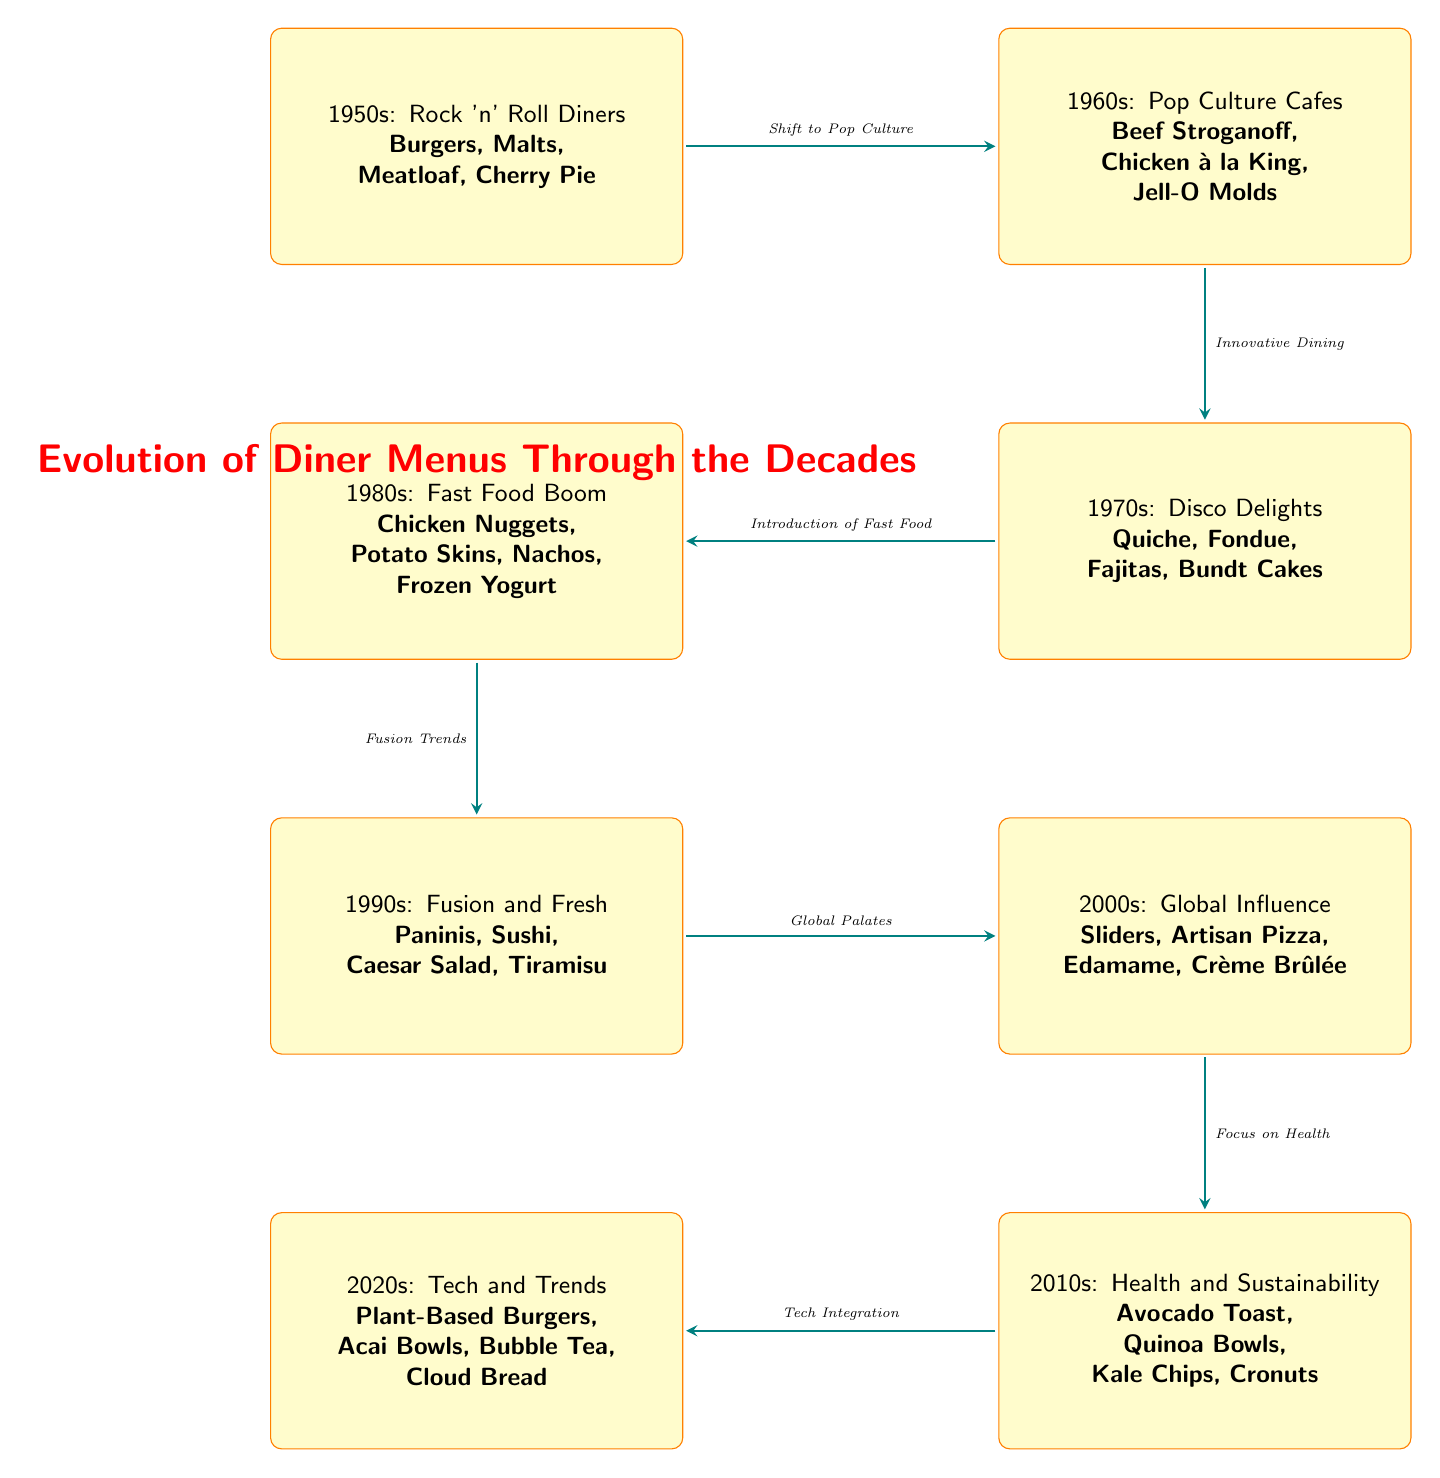What were the popular foods in the 1950s? The diagram lists the popular foods in the 1950s as "Burgers, Malts, Meatloaf, Cherry Pie." This information is directly extracted from the node labeled "1950s."
Answer: Burgers, Malts, Meatloaf, Cherry Pie Which decade introduced Fajitas? The diagram shows that Fajitas were introduced in the 1970s under the node labeled "1970s: Disco Delights." Hence, Fajitas belong to the 1970s era.
Answer: 1970s How many distinct decades are represented in the diagram? The diagram includes nodes for each decade from the 1950s to the 2020s, totaling eight distinct decades depicted. Therefore, the answer is derived by counting the nodes from "1950s" to "2020s."
Answer: 8 What is the main trend from the 1990s to the 2000s? The diagram notes the shift from "Fusion and Fresh" in the 1990s to "Global Influence" in the 2000s. Therefore, the trend indicates increasing globalization in diner menus.
Answer: Global Influence What foods mark the 2020s in the diagram? According to the node for the 2020s, the detailed foods listed are "Plant-Based Burgers, Acai Bowls, Bubble Tea, Cloud Bread." This information is retrieved from the respective node encapsulating the 2020s theme.
Answer: Plant-Based Burgers, Acai Bowls, Bubble Tea, Cloud Bread Which decade's food choices were driven by health trends? The diagram describes the 2010s as being focused on health and sustainability, thus indicating that this decade’s menu choices were heavily influenced by health trends.
Answer: 2010s What is the relationship between the 1980s and the 1990s? The diagram shows that the 1980s marked an era associated with fast food and that it led to fusion trends in the 1990s. This correlation is depicted through an arrow connecting the two nodes.
Answer: Fusion Trends How did diner menus shift from the 1960s to the 1970s? The arrow indicating a progression from the 1960s to the 1970s is labeled with "Innovative Dining," signaling a transition in dining styles that influenced the food menu choices for the 1970s.
Answer: Innovative Dining 